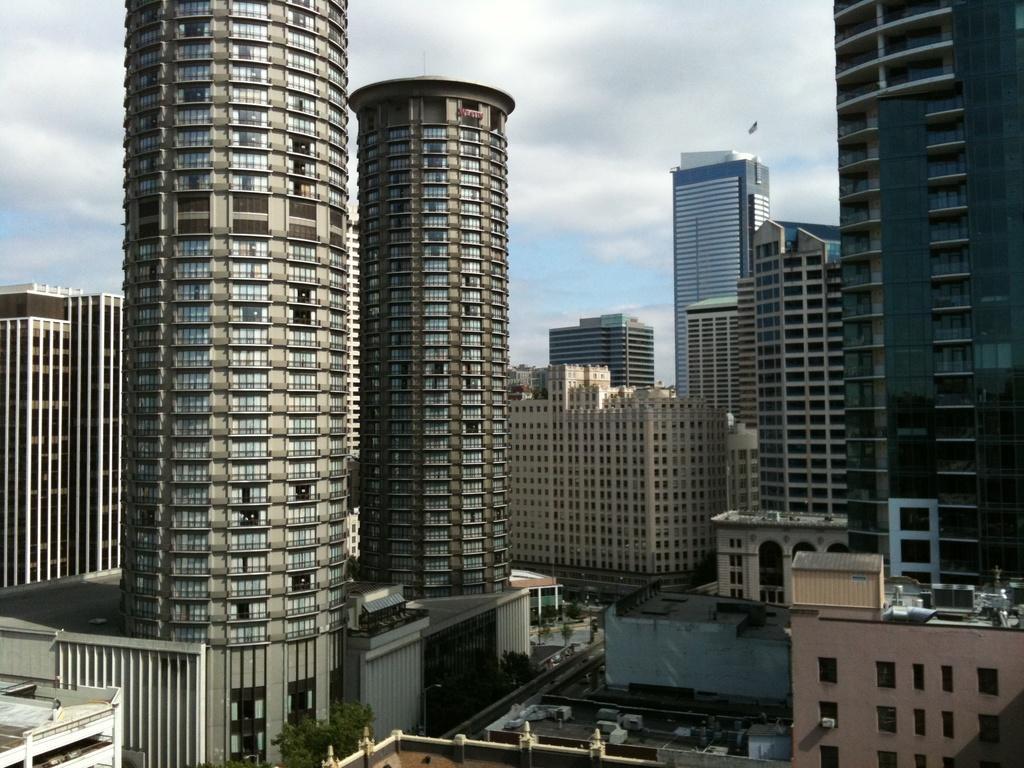Please provide a concise description of this image. In this image there are buildings, in the background there is a cloudy sky. 